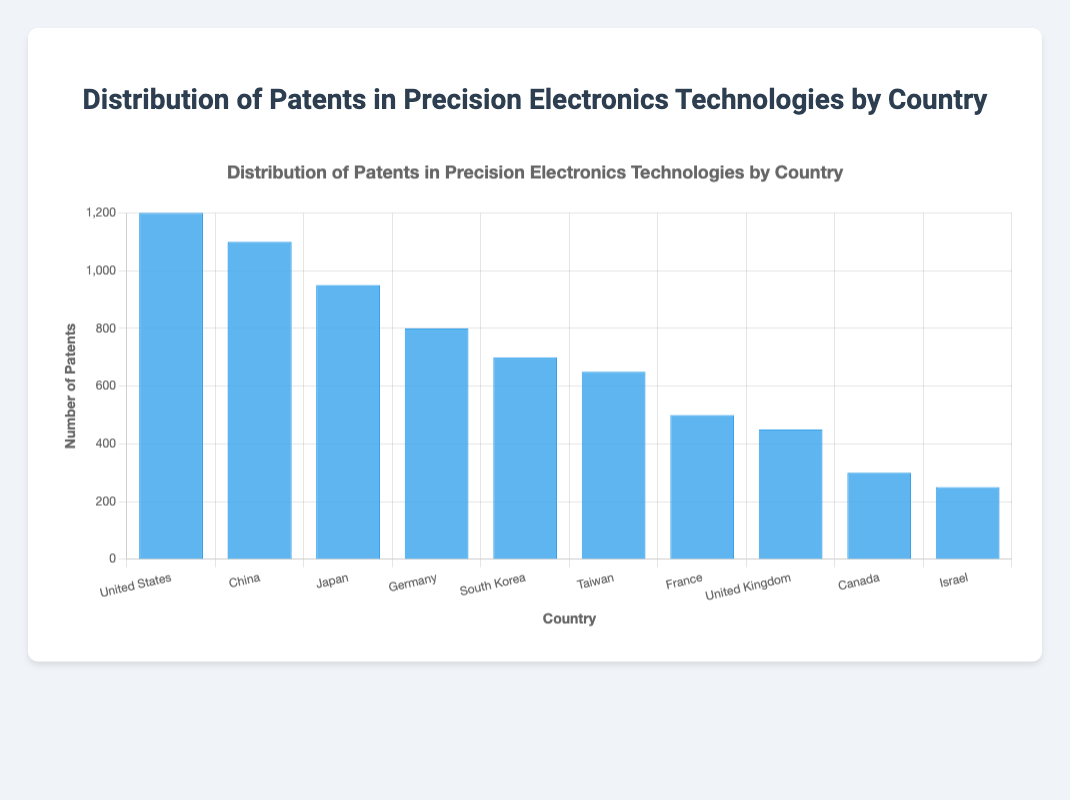Which country has the highest number of patents? By looking at the height of the bars, the United States has the tallest bar, indicating it has the highest number of patents.
Answer: United States Which two countries together hold the largest total number of patents? To find this, add the patents of the top two countries: United States (1200) and China (1100). The total is 1200 + 1100 = 2300.
Answer: United States and China How many more patents does Japan have than Canada? By subtracting the number of patents Canada has (300) from the number of patents Japan has (950), we get 950 - 300 = 650.
Answer: 650 Which country has fewer patents, Israel or the United Kingdom? Comparing the height of the bars, Israel has 250 patents while the United Kingdom has 450 patents, making Israel the country with fewer patents.
Answer: Israel What is the average number of patents for the top 3 countries? Sum the number of patents for the top 3 countries: United States (1200), China (1100), and Japan (950). The total is 1200 + 1100 + 950 = 3250. The average is 3250/3 = 1083.33.
Answer: 1083.33 What is the total number of patents from South Korea, Taiwan, and France combined? Add the patents from South Korea (700), Taiwan (650), and France (500). The total is 700 + 650 + 500 = 1850.
Answer: 1850 Are there more patents in Germany or Taiwan? By comparing the bars, Germany has 800 patents while Taiwan has 650 patents, which indicates Germany has more.
Answer: Germany Which country stands in the middle if we rank the countries by the number of patents? Counting the number of countries and locating the median, Taiwan, with 650 patents, is the middle country when ranked by number of patents.
Answer: Taiwan What is the difference in the number of patents between France and South Korea? Subtract France's patents (500) from South Korea's (700). The difference is 700 - 500 = 200.
Answer: 200 How many countries have more than 500 patents according to the chart? By visual inspection, the countries with more than 500 patents are the United States, China, Japan, Germany, South Korea, and Taiwan, making it a total of 6 countries.
Answer: 6 